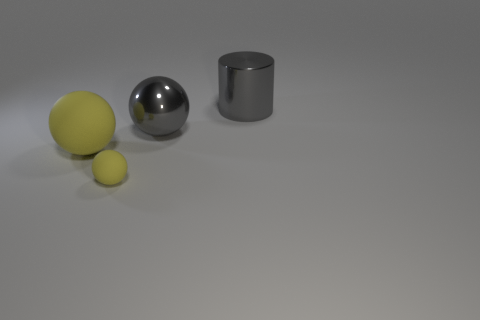What number of things are either yellow matte spheres left of the small yellow matte object or large things that are on the left side of the large gray shiny sphere?
Your response must be concise. 1. How many gray metal cylinders are in front of the gray thing that is in front of the large metal object that is behind the metallic sphere?
Offer a very short reply. 0. What size is the thing left of the tiny sphere?
Give a very brief answer. Large. What number of gray metallic spheres have the same size as the cylinder?
Provide a short and direct response. 1. There is a shiny cylinder; is it the same size as the matte thing that is right of the big yellow rubber ball?
Offer a terse response. No. What number of things are either small red balls or metal objects?
Offer a terse response. 2. How many other big metal cylinders are the same color as the cylinder?
Make the answer very short. 0. What is the shape of the gray shiny object that is the same size as the gray metal ball?
Provide a short and direct response. Cylinder. Is there another gray shiny object that has the same shape as the small object?
Provide a short and direct response. Yes. What number of big gray cylinders are made of the same material as the small sphere?
Offer a very short reply. 0. 